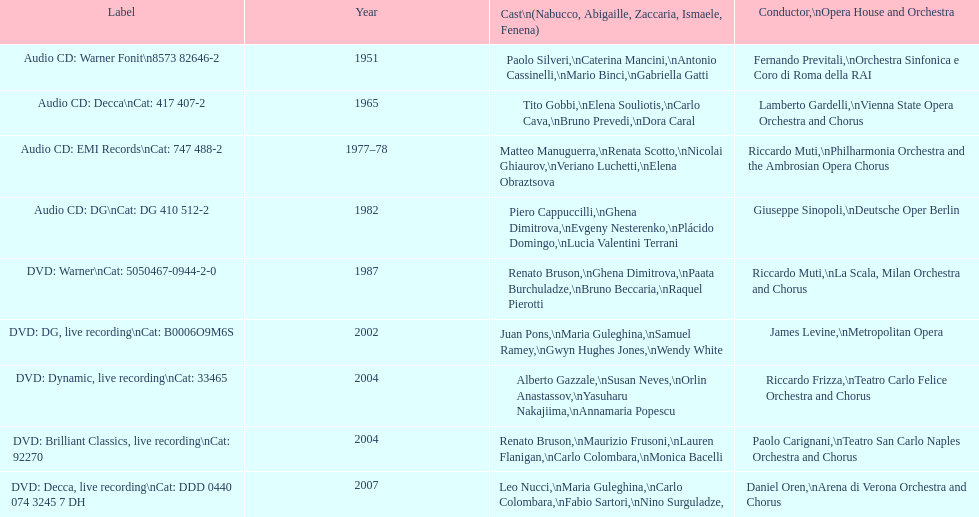How many recordings of nabucco have been made? 9. 